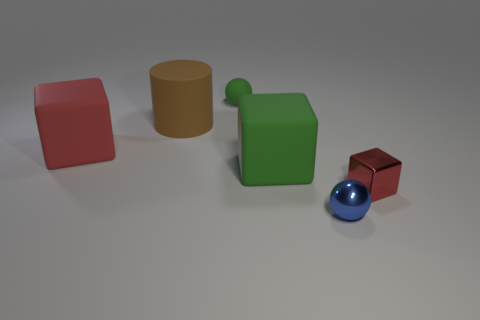Add 2 small blue metallic spheres. How many objects exist? 8 Subtract all spheres. How many objects are left? 4 Subtract all blocks. Subtract all cylinders. How many objects are left? 2 Add 1 large red objects. How many large red objects are left? 2 Add 6 large brown matte cylinders. How many large brown matte cylinders exist? 7 Subtract 0 yellow spheres. How many objects are left? 6 